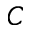Convert formula to latex. <formula><loc_0><loc_0><loc_500><loc_500>C</formula> 